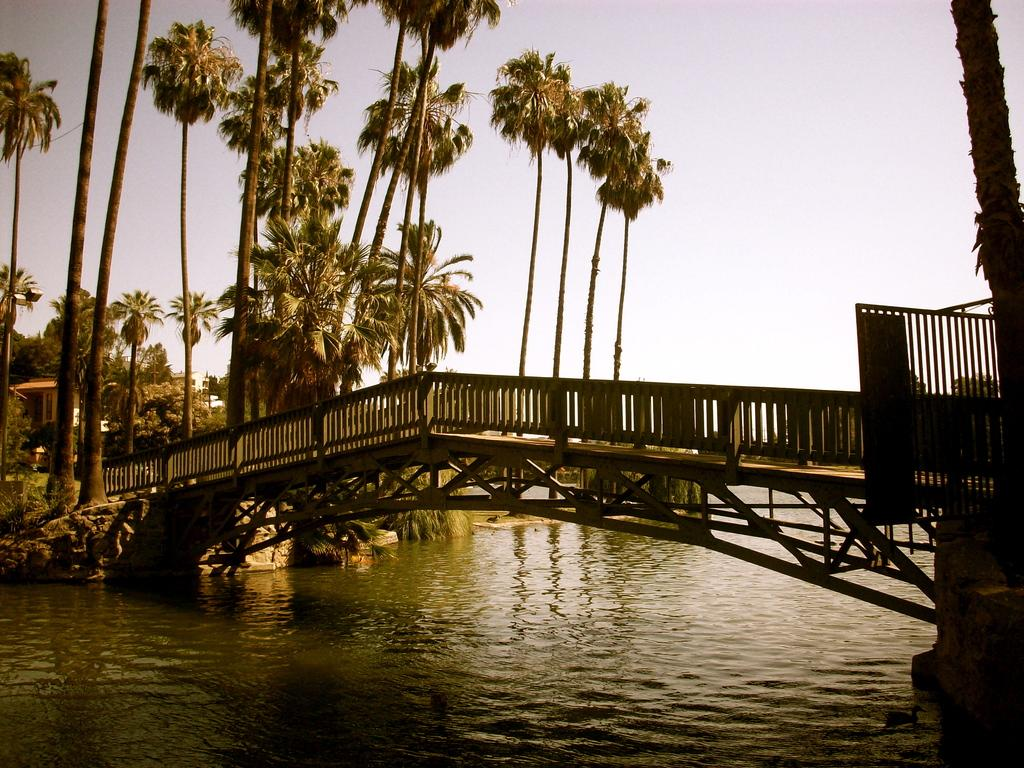What is located in the front of the image? There is water in the front of the image. What is built over the water? There is a bridge over the water. What can be seen in the background of the image? There are trees and a building in the background of the image. What else is visible in the background of the image? The sky is visible in the background of the image. Can you see a brush being used to paint the scene in the image? There is no brush or painting activity depicted in the image. Are there any ants visible on the bridge in the image? There are no ants present in the image. 